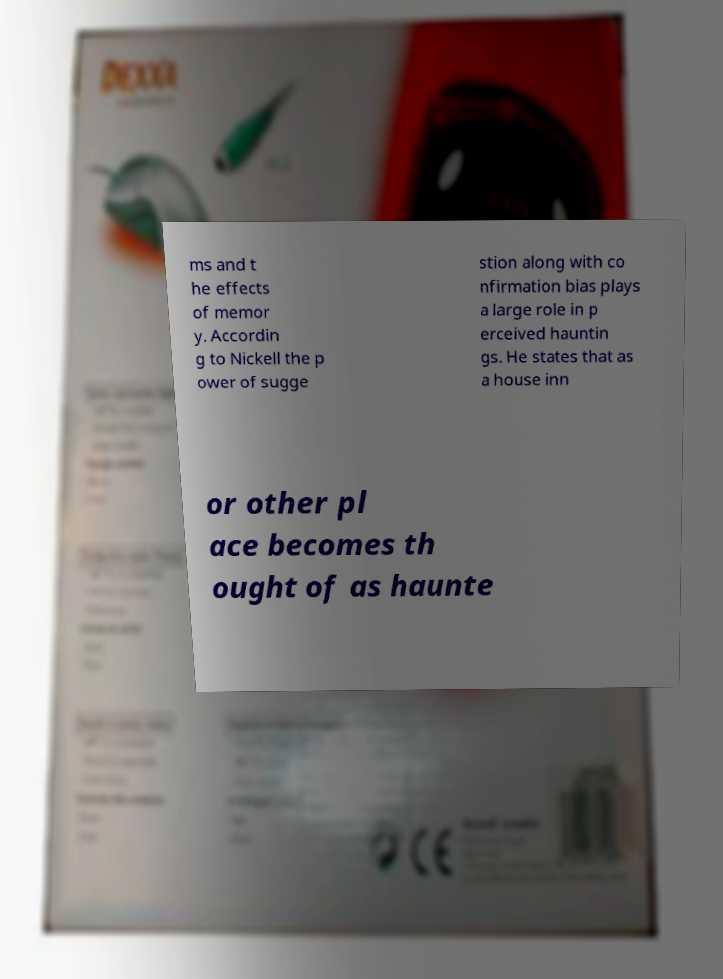For documentation purposes, I need the text within this image transcribed. Could you provide that? ms and t he effects of memor y. Accordin g to Nickell the p ower of sugge stion along with co nfirmation bias plays a large role in p erceived hauntin gs. He states that as a house inn or other pl ace becomes th ought of as haunte 